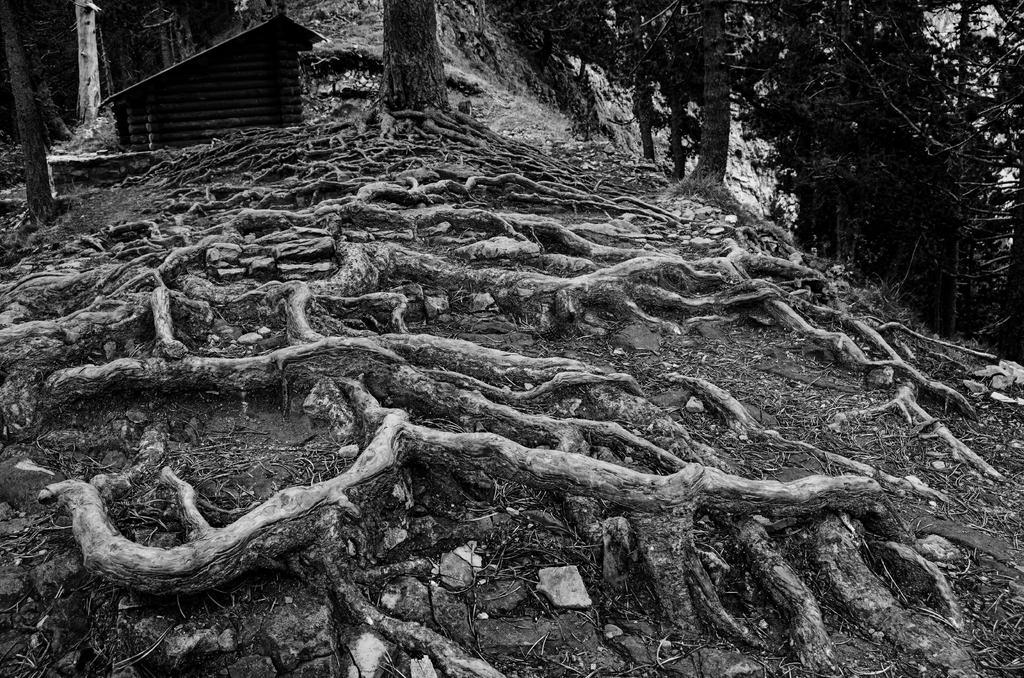Can you describe this image briefly? These are the roots of a tree, in the left side it looks like a shed. In the right side there are trees. 